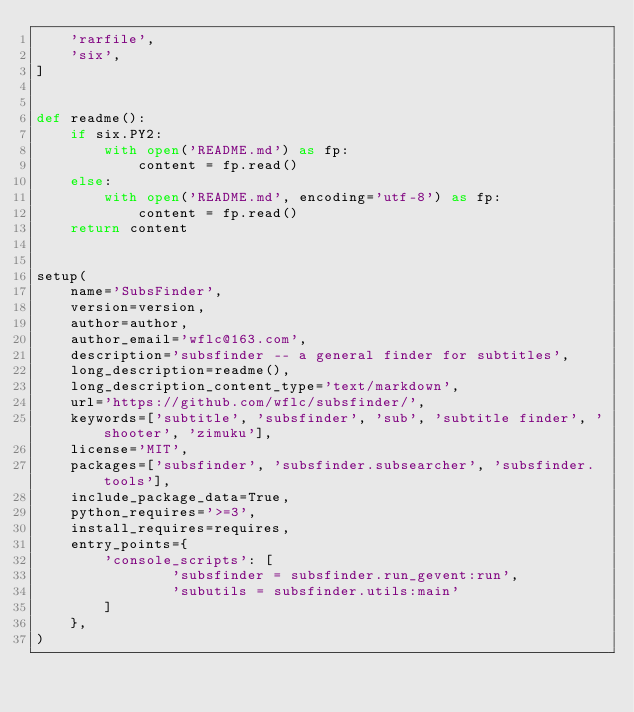<code> <loc_0><loc_0><loc_500><loc_500><_Python_>    'rarfile',
    'six',
]


def readme():
    if six.PY2:
        with open('README.md') as fp:
            content = fp.read()
    else:
        with open('README.md', encoding='utf-8') as fp:
            content = fp.read()
    return content


setup(
    name='SubsFinder',
    version=version,
    author=author,
    author_email='wflc@163.com',
    description='subsfinder -- a general finder for subtitles',
    long_description=readme(),
    long_description_content_type='text/markdown',
    url='https://github.com/wflc/subsfinder/',
    keywords=['subtitle', 'subsfinder', 'sub', 'subtitle finder', 'shooter', 'zimuku'],
    license='MIT',
    packages=['subsfinder', 'subsfinder.subsearcher', 'subsfinder.tools'],
    include_package_data=True,
    python_requires='>=3',
    install_requires=requires,
    entry_points={
        'console_scripts': [
                'subsfinder = subsfinder.run_gevent:run',
                'subutils = subsfinder.utils:main'
        ]
    },
)
</code> 